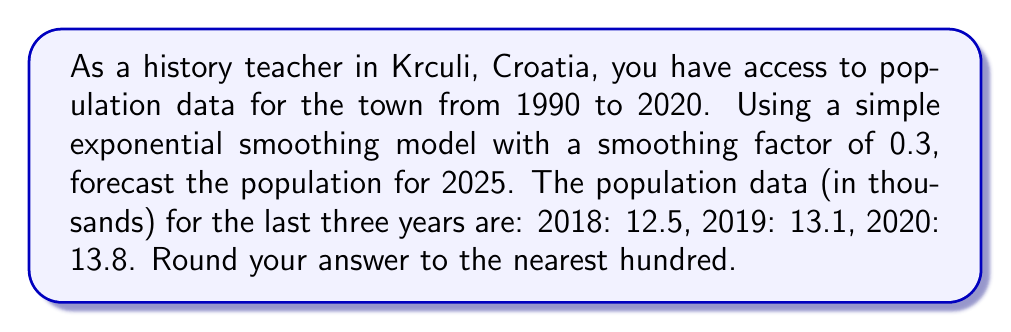Help me with this question. Let's approach this step-by-step using the simple exponential smoothing method:

1) The simple exponential smoothing formula is:
   $$F_{t+1} = \alpha Y_t + (1-\alpha) F_t$$
   where $F_{t+1}$ is the forecast for the next period, $Y_t$ is the actual value at time $t$, $F_t$ is the forecast for time $t$, and $\alpha$ is the smoothing factor.

2) We're given $\alpha = 0.3$

3) Let's start with 2018 as our initial forecast:
   $F_{2018} = 12.5$

4) For 2019:
   $F_{2019} = 0.3 * 12.5 + 0.7 * 12.5 = 12.5$

5) For 2020:
   $F_{2020} = 0.3 * 13.1 + 0.7 * 12.5 = 12.68$

6) For 2021:
   $F_{2021} = 0.3 * 13.8 + 0.7 * 12.68 = 13.016$

7) We need to forecast for the next 4 years (2022, 2023, 2024, 2025). Since we don't have actual values, we'll use the previous forecast:

   For 2022: $F_{2022} = 0.3 * 13.016 + 0.7 * 13.016 = 13.016$
   For 2023: $F_{2023} = 13.016$
   For 2024: $F_{2024} = 13.016$
   For 2025: $F_{2025} = 13.016$

8) Rounding to the nearest hundred: 13,000
Answer: 13,000 